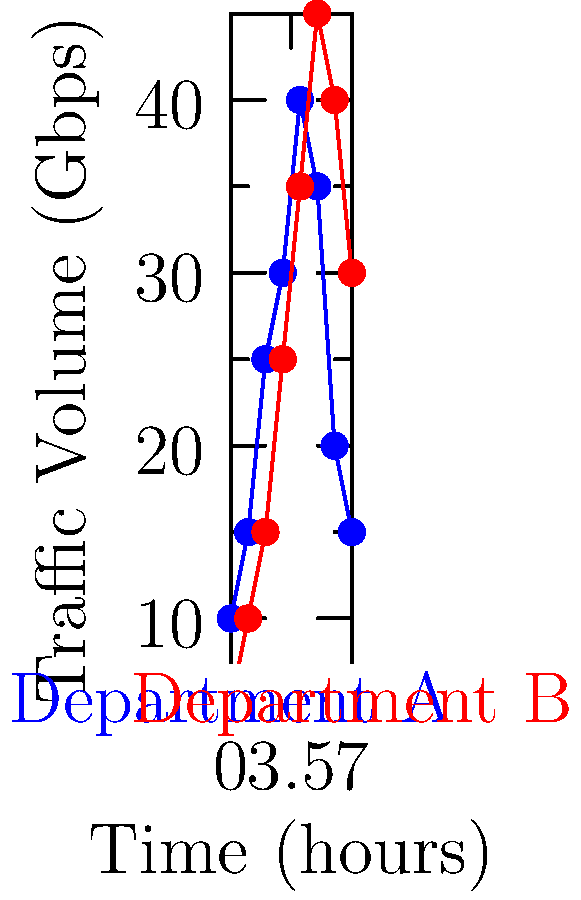As the undersecretary overseeing network operations, you're presented with a line graph showing network traffic patterns for two government departments over an 8-hour period. Which department experiences its peak traffic earlier in the day, and what is the maximum difference in traffic volume between the two departments? To answer this question, we need to analyze the line graph and follow these steps:

1. Identify the peak traffic for each department:
   - Department A (blue line) peaks at hour 4 with approximately 40 Gbps
   - Department B (red line) peaks at hour 5 with approximately 45 Gbps

2. Compare the timing of peak traffic:
   Department A reaches its peak earlier (at hour 4) compared to Department B (at hour 5)

3. Calculate the maximum difference in traffic volume:
   - Examine each time point and calculate the difference between the two departments
   - The largest difference appears to be at hour 7, where:
     Department B: approximately 40 Gbps
     Department A: approximately 20 Gbps
   - Maximum difference: 40 Gbps - 20 Gbps = 20 Gbps

Therefore, Department A experiences its peak traffic earlier in the day, and the maximum difference in traffic volume between the two departments is approximately 20 Gbps.
Answer: Department A; 20 Gbps 